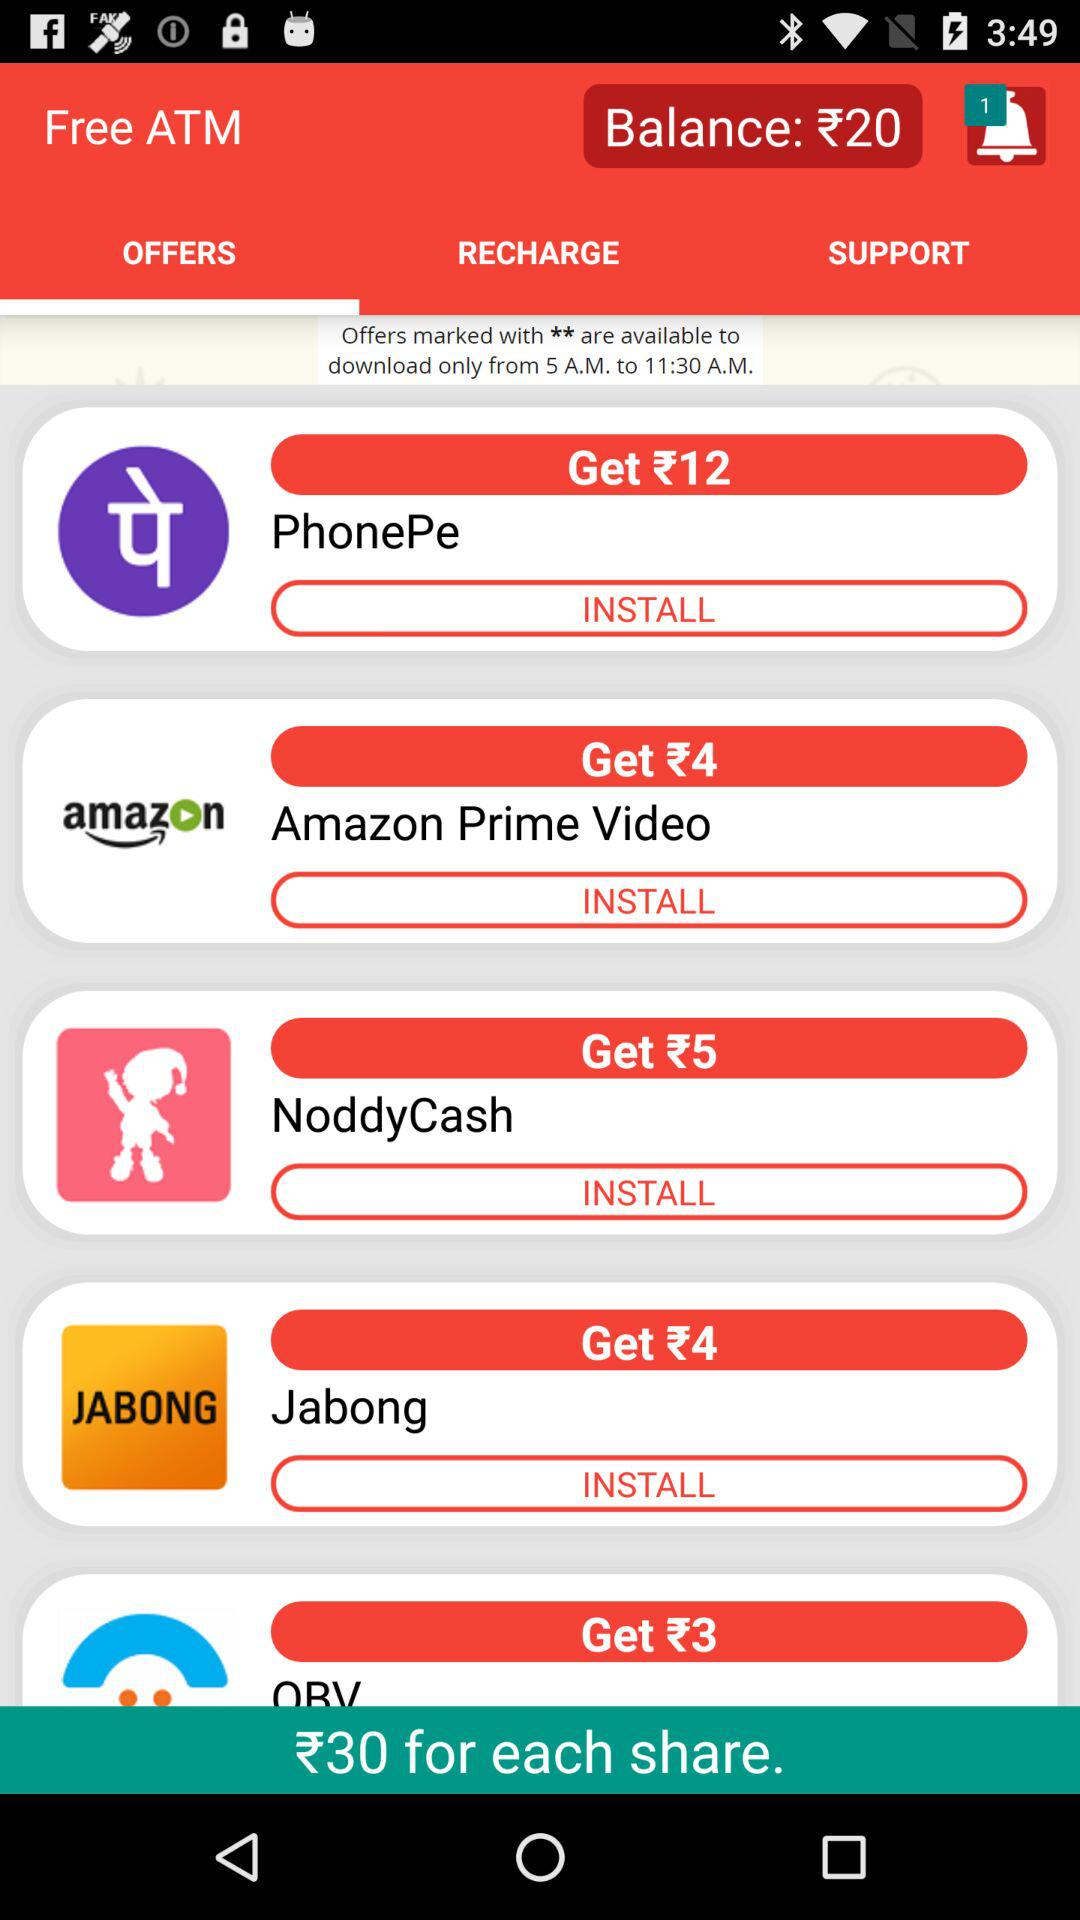What is the balance amount? The balance amount is ₹20. 